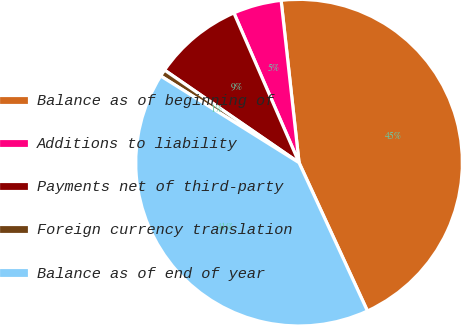Convert chart. <chart><loc_0><loc_0><loc_500><loc_500><pie_chart><fcel>Balance as of beginning of<fcel>Additions to liability<fcel>Payments net of third-party<fcel>Foreign currency translation<fcel>Balance as of end of year<nl><fcel>44.87%<fcel>4.78%<fcel>8.87%<fcel>0.69%<fcel>40.78%<nl></chart> 